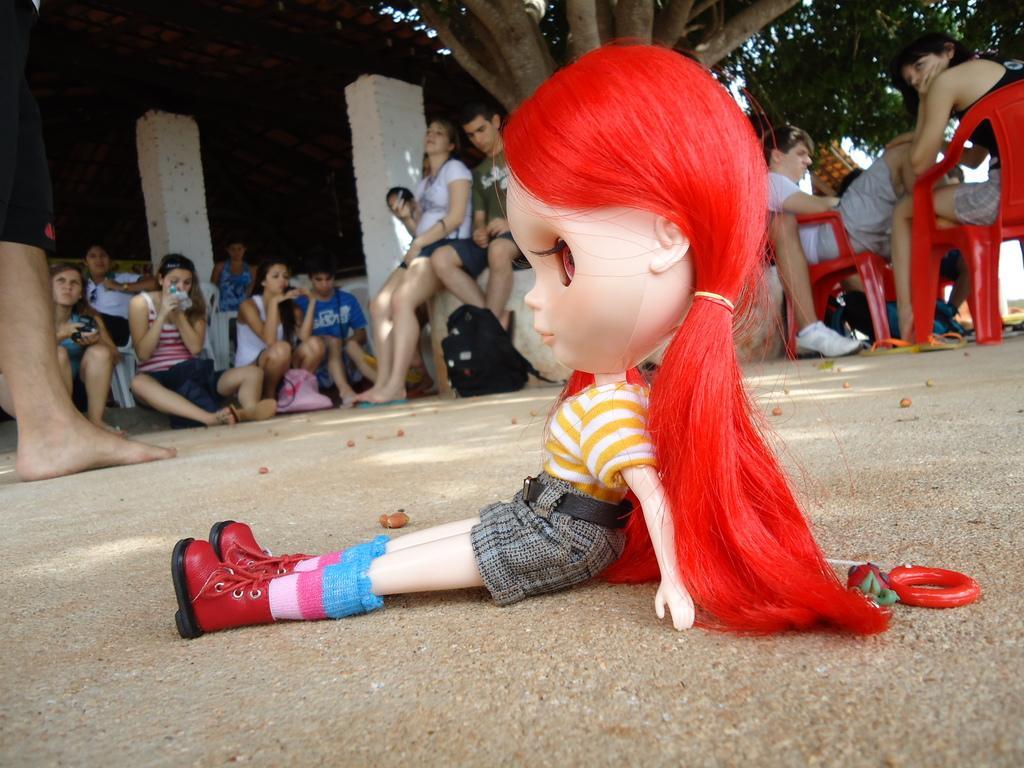Please provide a concise description of this image. In this image in the front there is a doll. In the background there are persons sitting and there are trees and there are pillars. 